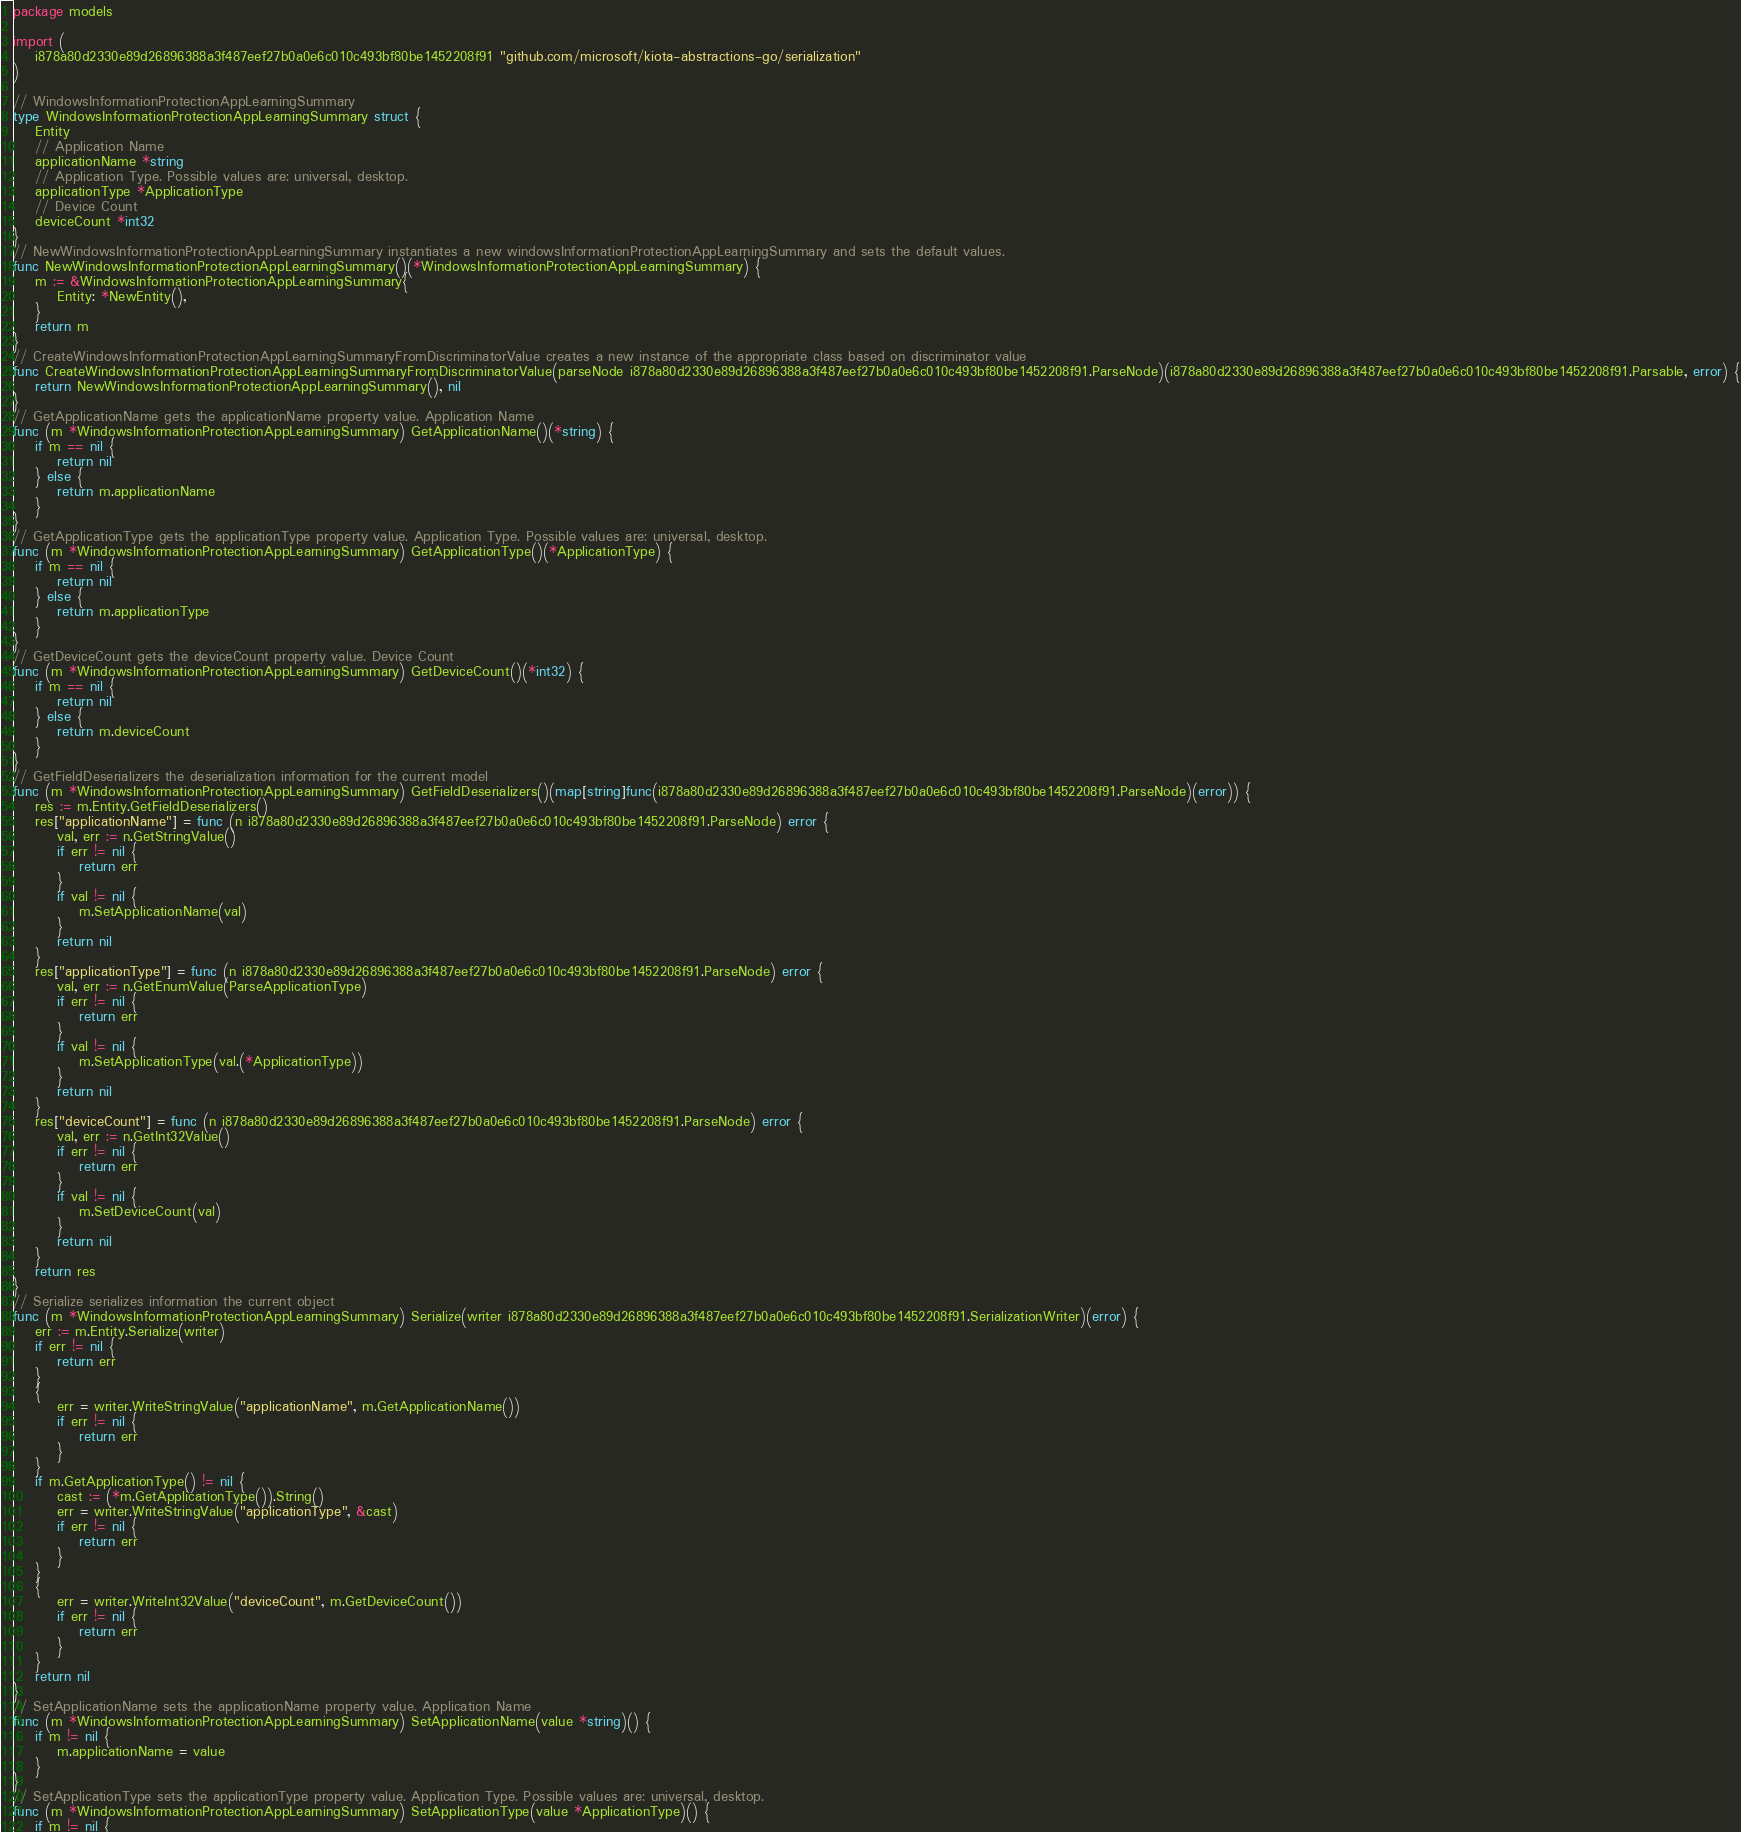Convert code to text. <code><loc_0><loc_0><loc_500><loc_500><_Go_>package models

import (
    i878a80d2330e89d26896388a3f487eef27b0a0e6c010c493bf80be1452208f91 "github.com/microsoft/kiota-abstractions-go/serialization"
)

// WindowsInformationProtectionAppLearningSummary 
type WindowsInformationProtectionAppLearningSummary struct {
    Entity
    // Application Name
    applicationName *string
    // Application Type. Possible values are: universal, desktop.
    applicationType *ApplicationType
    // Device Count
    deviceCount *int32
}
// NewWindowsInformationProtectionAppLearningSummary instantiates a new windowsInformationProtectionAppLearningSummary and sets the default values.
func NewWindowsInformationProtectionAppLearningSummary()(*WindowsInformationProtectionAppLearningSummary) {
    m := &WindowsInformationProtectionAppLearningSummary{
        Entity: *NewEntity(),
    }
    return m
}
// CreateWindowsInformationProtectionAppLearningSummaryFromDiscriminatorValue creates a new instance of the appropriate class based on discriminator value
func CreateWindowsInformationProtectionAppLearningSummaryFromDiscriminatorValue(parseNode i878a80d2330e89d26896388a3f487eef27b0a0e6c010c493bf80be1452208f91.ParseNode)(i878a80d2330e89d26896388a3f487eef27b0a0e6c010c493bf80be1452208f91.Parsable, error) {
    return NewWindowsInformationProtectionAppLearningSummary(), nil
}
// GetApplicationName gets the applicationName property value. Application Name
func (m *WindowsInformationProtectionAppLearningSummary) GetApplicationName()(*string) {
    if m == nil {
        return nil
    } else {
        return m.applicationName
    }
}
// GetApplicationType gets the applicationType property value. Application Type. Possible values are: universal, desktop.
func (m *WindowsInformationProtectionAppLearningSummary) GetApplicationType()(*ApplicationType) {
    if m == nil {
        return nil
    } else {
        return m.applicationType
    }
}
// GetDeviceCount gets the deviceCount property value. Device Count
func (m *WindowsInformationProtectionAppLearningSummary) GetDeviceCount()(*int32) {
    if m == nil {
        return nil
    } else {
        return m.deviceCount
    }
}
// GetFieldDeserializers the deserialization information for the current model
func (m *WindowsInformationProtectionAppLearningSummary) GetFieldDeserializers()(map[string]func(i878a80d2330e89d26896388a3f487eef27b0a0e6c010c493bf80be1452208f91.ParseNode)(error)) {
    res := m.Entity.GetFieldDeserializers()
    res["applicationName"] = func (n i878a80d2330e89d26896388a3f487eef27b0a0e6c010c493bf80be1452208f91.ParseNode) error {
        val, err := n.GetStringValue()
        if err != nil {
            return err
        }
        if val != nil {
            m.SetApplicationName(val)
        }
        return nil
    }
    res["applicationType"] = func (n i878a80d2330e89d26896388a3f487eef27b0a0e6c010c493bf80be1452208f91.ParseNode) error {
        val, err := n.GetEnumValue(ParseApplicationType)
        if err != nil {
            return err
        }
        if val != nil {
            m.SetApplicationType(val.(*ApplicationType))
        }
        return nil
    }
    res["deviceCount"] = func (n i878a80d2330e89d26896388a3f487eef27b0a0e6c010c493bf80be1452208f91.ParseNode) error {
        val, err := n.GetInt32Value()
        if err != nil {
            return err
        }
        if val != nil {
            m.SetDeviceCount(val)
        }
        return nil
    }
    return res
}
// Serialize serializes information the current object
func (m *WindowsInformationProtectionAppLearningSummary) Serialize(writer i878a80d2330e89d26896388a3f487eef27b0a0e6c010c493bf80be1452208f91.SerializationWriter)(error) {
    err := m.Entity.Serialize(writer)
    if err != nil {
        return err
    }
    {
        err = writer.WriteStringValue("applicationName", m.GetApplicationName())
        if err != nil {
            return err
        }
    }
    if m.GetApplicationType() != nil {
        cast := (*m.GetApplicationType()).String()
        err = writer.WriteStringValue("applicationType", &cast)
        if err != nil {
            return err
        }
    }
    {
        err = writer.WriteInt32Value("deviceCount", m.GetDeviceCount())
        if err != nil {
            return err
        }
    }
    return nil
}
// SetApplicationName sets the applicationName property value. Application Name
func (m *WindowsInformationProtectionAppLearningSummary) SetApplicationName(value *string)() {
    if m != nil {
        m.applicationName = value
    }
}
// SetApplicationType sets the applicationType property value. Application Type. Possible values are: universal, desktop.
func (m *WindowsInformationProtectionAppLearningSummary) SetApplicationType(value *ApplicationType)() {
    if m != nil {</code> 